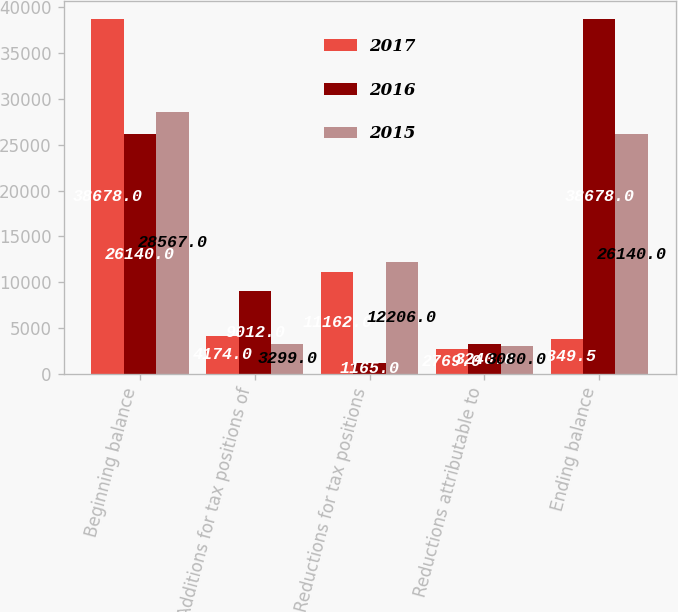Convert chart to OTSL. <chart><loc_0><loc_0><loc_500><loc_500><stacked_bar_chart><ecel><fcel>Beginning balance<fcel>Additions for tax positions of<fcel>Reductions for tax positions<fcel>Reductions attributable to<fcel>Ending balance<nl><fcel>2017<fcel>38678<fcel>4174<fcel>11162<fcel>2769<fcel>3849.5<nl><fcel>2016<fcel>26140<fcel>9012<fcel>1165<fcel>3240<fcel>38678<nl><fcel>2015<fcel>28567<fcel>3299<fcel>12206<fcel>3080<fcel>26140<nl></chart> 